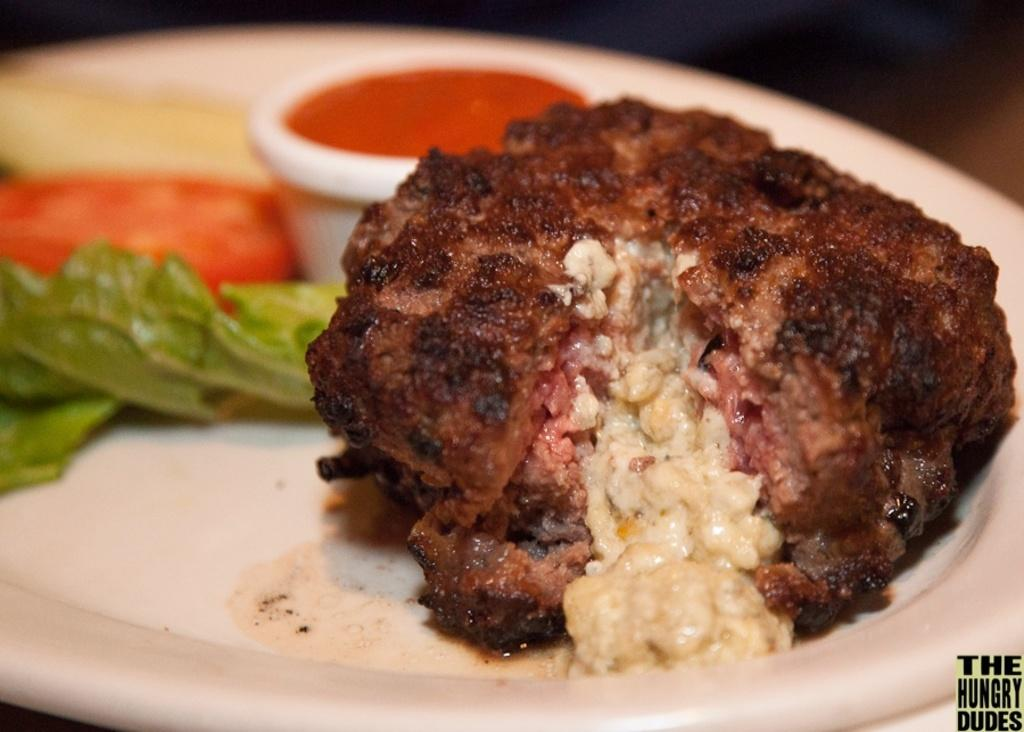What is on the plate that is visible in the image? There is a plate with food in the image. What condiment is present in the image? There is a bowl of ketchup in the image. Where is the text located in the image? The text is in the bottom right corner of the image. What type of advice is the dog giving in the image? There is no dog present in the image, so it is not possible to determine what advice the dog might be giving. 